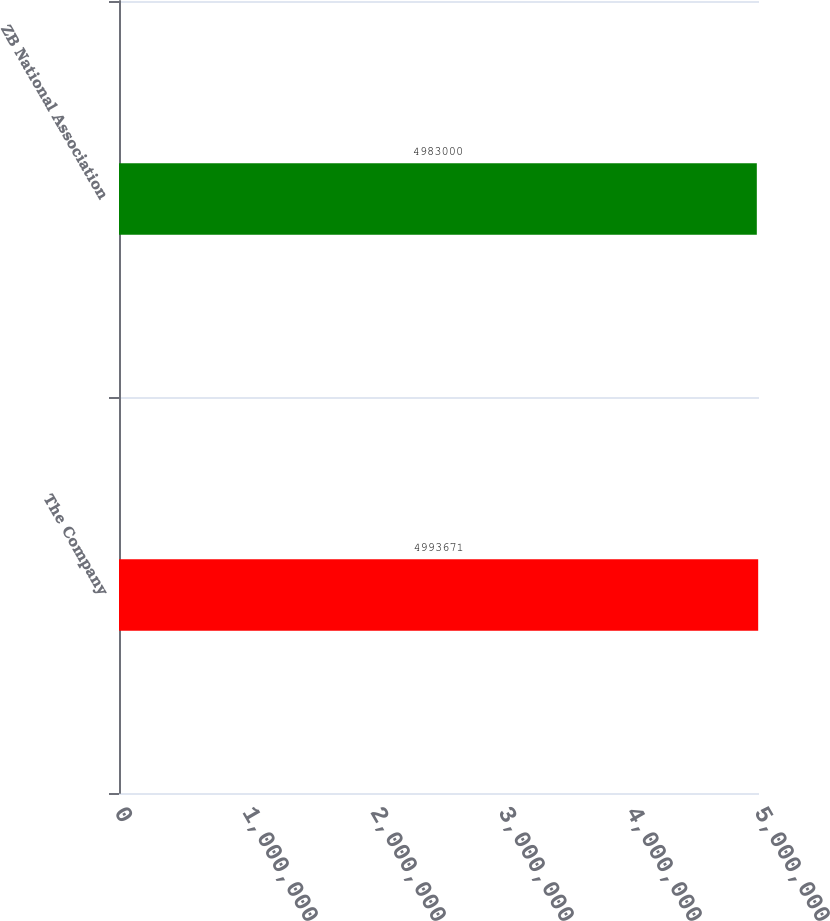<chart> <loc_0><loc_0><loc_500><loc_500><bar_chart><fcel>The Company<fcel>ZB National Association<nl><fcel>4.99367e+06<fcel>4.983e+06<nl></chart> 